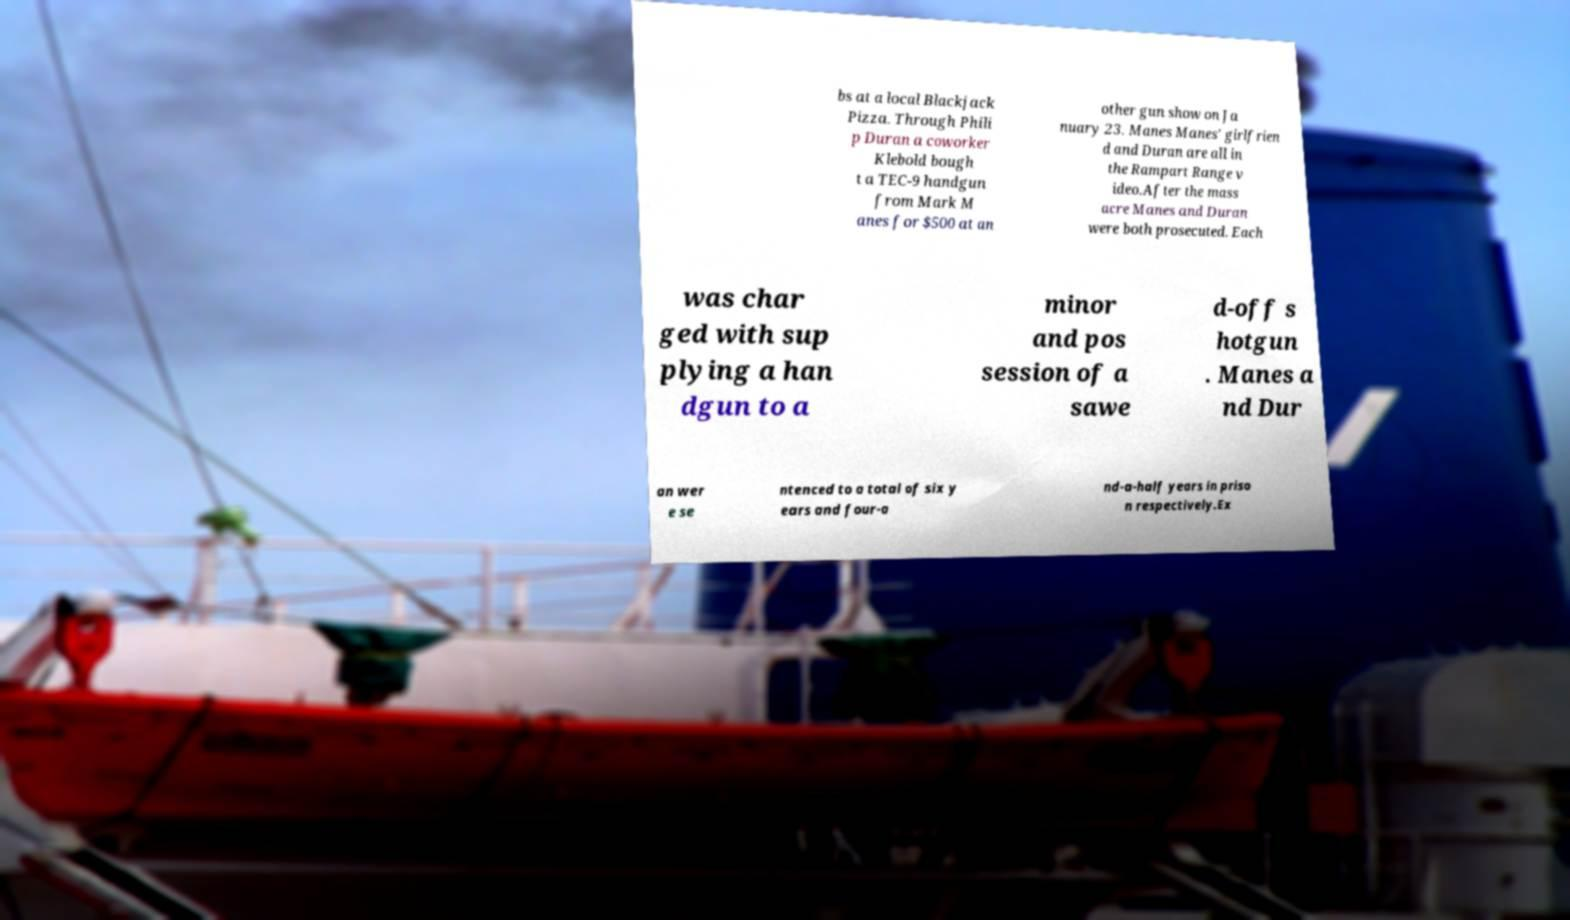There's text embedded in this image that I need extracted. Can you transcribe it verbatim? bs at a local Blackjack Pizza. Through Phili p Duran a coworker Klebold bough t a TEC-9 handgun from Mark M anes for $500 at an other gun show on Ja nuary 23. Manes Manes' girlfrien d and Duran are all in the Rampart Range v ideo.After the mass acre Manes and Duran were both prosecuted. Each was char ged with sup plying a han dgun to a minor and pos session of a sawe d-off s hotgun . Manes a nd Dur an wer e se ntenced to a total of six y ears and four-a nd-a-half years in priso n respectively.Ex 